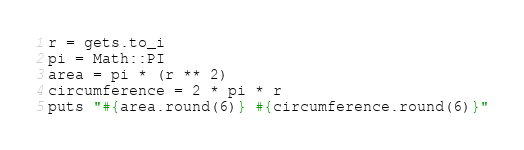Convert code to text. <code><loc_0><loc_0><loc_500><loc_500><_Ruby_>r = gets.to_i
pi = Math::PI
area = pi * (r ** 2)
circumference = 2 * pi * r
puts "#{area.round(6)} #{circumference.round(6)}"</code> 